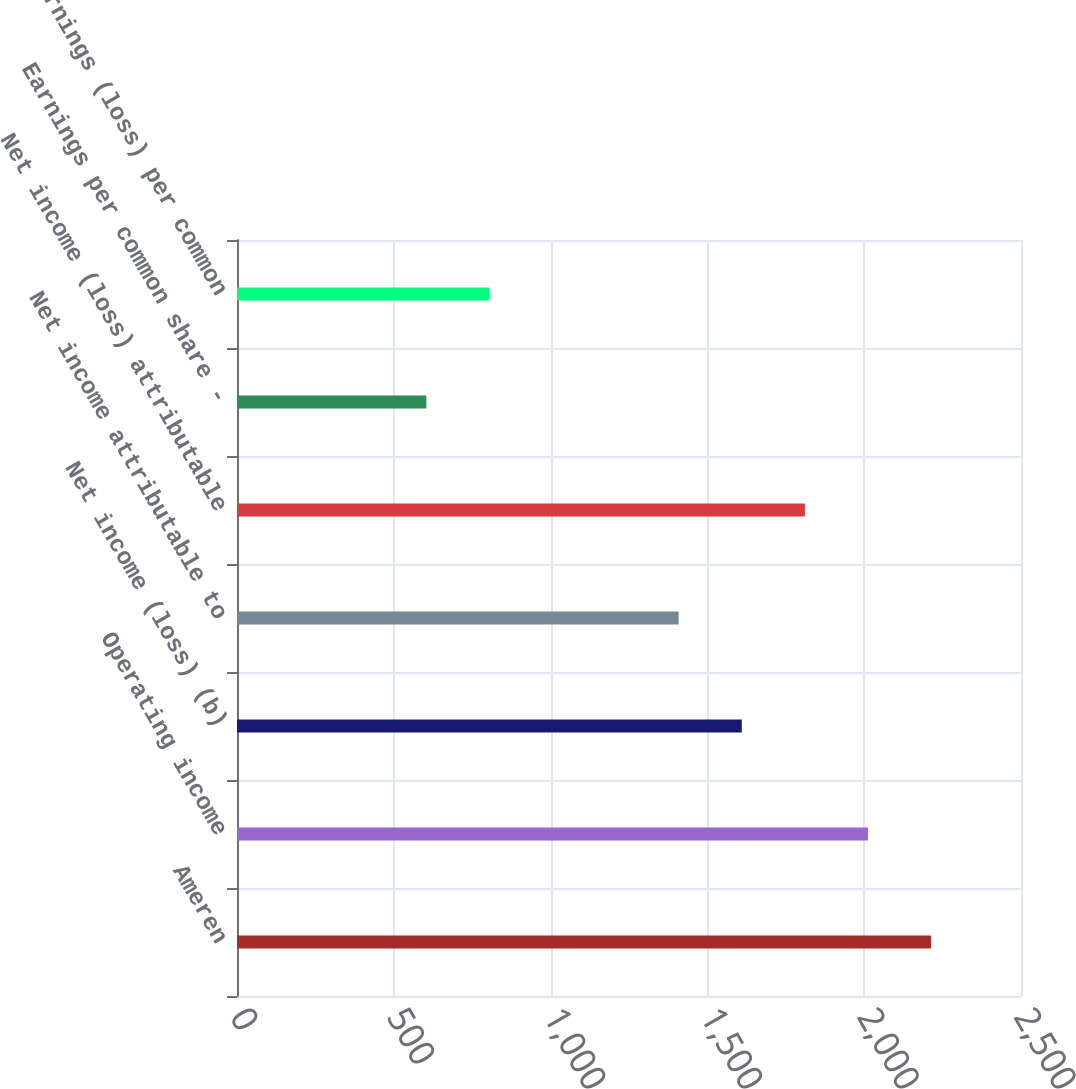Convert chart. <chart><loc_0><loc_0><loc_500><loc_500><bar_chart><fcel>Ameren<fcel>Operating income<fcel>Net income (loss) (b)<fcel>Net income attributable to<fcel>Net income (loss) attributable<fcel>Earnings per common share -<fcel>Earnings (loss) per common<nl><fcel>2213.18<fcel>2012<fcel>1609.64<fcel>1408.46<fcel>1810.82<fcel>603.74<fcel>804.92<nl></chart> 